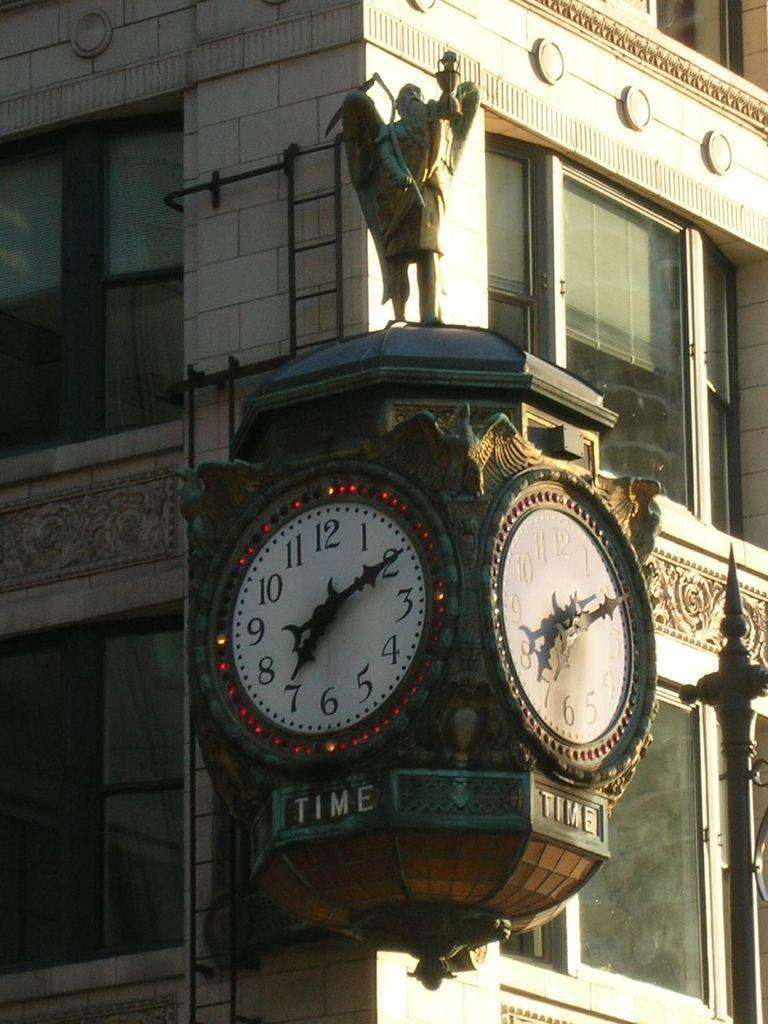<image>
Create a compact narrative representing the image presented. An ornate clock on a building has the word TIME beneath it. 